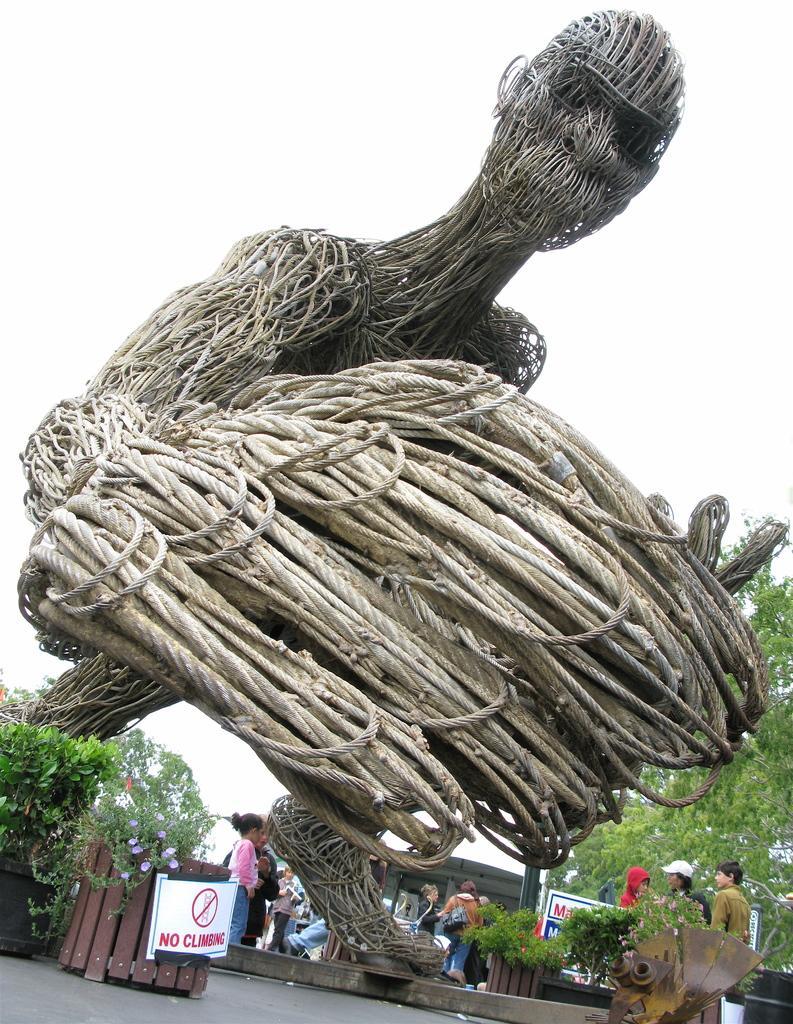Can you describe this image briefly? In this image I see the depiction of a person which is made of ropes and I see plants and I see number of people and I see the tree over here. In the background I see the clear sky and I see the path. 